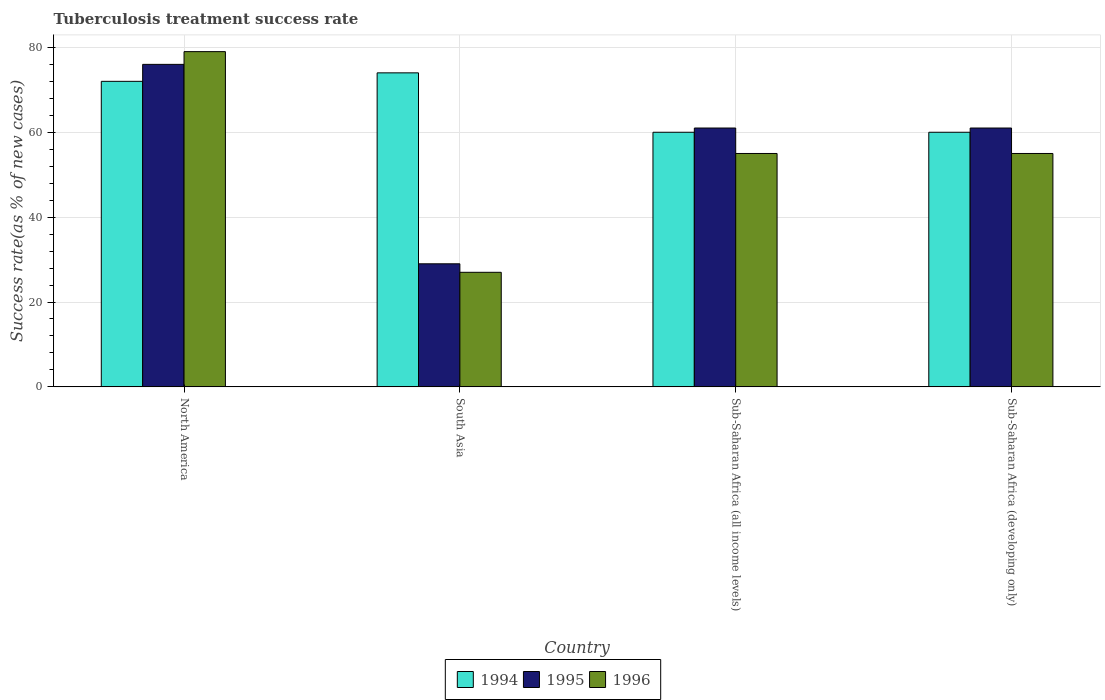How many different coloured bars are there?
Your answer should be very brief. 3. How many groups of bars are there?
Provide a succinct answer. 4. Are the number of bars on each tick of the X-axis equal?
Keep it short and to the point. Yes. How many bars are there on the 1st tick from the right?
Your answer should be very brief. 3. What is the label of the 1st group of bars from the left?
Give a very brief answer. North America. What is the tuberculosis treatment success rate in 1996 in Sub-Saharan Africa (developing only)?
Make the answer very short. 55. What is the total tuberculosis treatment success rate in 1996 in the graph?
Ensure brevity in your answer.  216. What is the difference between the tuberculosis treatment success rate in 1995 in South Asia and that in Sub-Saharan Africa (developing only)?
Offer a terse response. -32. What is the average tuberculosis treatment success rate in 1994 per country?
Your response must be concise. 66.5. In how many countries, is the tuberculosis treatment success rate in 1994 greater than 48 %?
Your answer should be very brief. 4. What is the ratio of the tuberculosis treatment success rate in 1995 in South Asia to that in Sub-Saharan Africa (all income levels)?
Give a very brief answer. 0.48. Is the tuberculosis treatment success rate in 1995 in North America less than that in South Asia?
Offer a very short reply. No. Is the difference between the tuberculosis treatment success rate in 1995 in North America and South Asia greater than the difference between the tuberculosis treatment success rate in 1994 in North America and South Asia?
Your answer should be very brief. Yes. In how many countries, is the tuberculosis treatment success rate in 1996 greater than the average tuberculosis treatment success rate in 1996 taken over all countries?
Keep it short and to the point. 3. Is the sum of the tuberculosis treatment success rate in 1994 in North America and Sub-Saharan Africa (all income levels) greater than the maximum tuberculosis treatment success rate in 1996 across all countries?
Give a very brief answer. Yes. What does the 3rd bar from the left in North America represents?
Offer a very short reply. 1996. How many bars are there?
Offer a very short reply. 12. Are the values on the major ticks of Y-axis written in scientific E-notation?
Your answer should be very brief. No. Does the graph contain any zero values?
Your answer should be very brief. No. Does the graph contain grids?
Provide a succinct answer. Yes. How many legend labels are there?
Provide a short and direct response. 3. What is the title of the graph?
Give a very brief answer. Tuberculosis treatment success rate. Does "1999" appear as one of the legend labels in the graph?
Offer a very short reply. No. What is the label or title of the Y-axis?
Provide a short and direct response. Success rate(as % of new cases). What is the Success rate(as % of new cases) in 1996 in North America?
Keep it short and to the point. 79. What is the Success rate(as % of new cases) in 1996 in Sub-Saharan Africa (all income levels)?
Your answer should be very brief. 55. What is the Success rate(as % of new cases) of 1994 in Sub-Saharan Africa (developing only)?
Ensure brevity in your answer.  60. Across all countries, what is the maximum Success rate(as % of new cases) of 1995?
Provide a succinct answer. 76. Across all countries, what is the maximum Success rate(as % of new cases) of 1996?
Provide a succinct answer. 79. Across all countries, what is the minimum Success rate(as % of new cases) in 1996?
Your answer should be compact. 27. What is the total Success rate(as % of new cases) of 1994 in the graph?
Provide a short and direct response. 266. What is the total Success rate(as % of new cases) in 1995 in the graph?
Your answer should be very brief. 227. What is the total Success rate(as % of new cases) of 1996 in the graph?
Provide a short and direct response. 216. What is the difference between the Success rate(as % of new cases) of 1995 in North America and that in South Asia?
Your answer should be very brief. 47. What is the difference between the Success rate(as % of new cases) of 1996 in North America and that in South Asia?
Provide a succinct answer. 52. What is the difference between the Success rate(as % of new cases) in 1995 in North America and that in Sub-Saharan Africa (all income levels)?
Your response must be concise. 15. What is the difference between the Success rate(as % of new cases) of 1996 in North America and that in Sub-Saharan Africa (all income levels)?
Offer a very short reply. 24. What is the difference between the Success rate(as % of new cases) in 1996 in North America and that in Sub-Saharan Africa (developing only)?
Offer a very short reply. 24. What is the difference between the Success rate(as % of new cases) of 1995 in South Asia and that in Sub-Saharan Africa (all income levels)?
Your response must be concise. -32. What is the difference between the Success rate(as % of new cases) of 1995 in South Asia and that in Sub-Saharan Africa (developing only)?
Make the answer very short. -32. What is the difference between the Success rate(as % of new cases) in 1996 in South Asia and that in Sub-Saharan Africa (developing only)?
Your answer should be compact. -28. What is the difference between the Success rate(as % of new cases) of 1994 in Sub-Saharan Africa (all income levels) and that in Sub-Saharan Africa (developing only)?
Your answer should be compact. 0. What is the difference between the Success rate(as % of new cases) in 1995 in Sub-Saharan Africa (all income levels) and that in Sub-Saharan Africa (developing only)?
Give a very brief answer. 0. What is the difference between the Success rate(as % of new cases) of 1994 in North America and the Success rate(as % of new cases) of 1996 in Sub-Saharan Africa (all income levels)?
Offer a very short reply. 17. What is the difference between the Success rate(as % of new cases) in 1994 in North America and the Success rate(as % of new cases) in 1996 in Sub-Saharan Africa (developing only)?
Make the answer very short. 17. What is the difference between the Success rate(as % of new cases) of 1994 in South Asia and the Success rate(as % of new cases) of 1995 in Sub-Saharan Africa (all income levels)?
Your answer should be compact. 13. What is the difference between the Success rate(as % of new cases) in 1994 in South Asia and the Success rate(as % of new cases) in 1996 in Sub-Saharan Africa (all income levels)?
Provide a short and direct response. 19. What is the difference between the Success rate(as % of new cases) of 1994 in South Asia and the Success rate(as % of new cases) of 1996 in Sub-Saharan Africa (developing only)?
Keep it short and to the point. 19. What is the difference between the Success rate(as % of new cases) in 1994 in Sub-Saharan Africa (all income levels) and the Success rate(as % of new cases) in 1996 in Sub-Saharan Africa (developing only)?
Your answer should be compact. 5. What is the average Success rate(as % of new cases) in 1994 per country?
Keep it short and to the point. 66.5. What is the average Success rate(as % of new cases) in 1995 per country?
Make the answer very short. 56.75. What is the average Success rate(as % of new cases) of 1996 per country?
Ensure brevity in your answer.  54. What is the difference between the Success rate(as % of new cases) of 1994 and Success rate(as % of new cases) of 1995 in North America?
Give a very brief answer. -4. What is the difference between the Success rate(as % of new cases) in 1994 and Success rate(as % of new cases) in 1996 in North America?
Offer a very short reply. -7. What is the difference between the Success rate(as % of new cases) in 1995 and Success rate(as % of new cases) in 1996 in North America?
Ensure brevity in your answer.  -3. What is the difference between the Success rate(as % of new cases) in 1994 and Success rate(as % of new cases) in 1995 in South Asia?
Make the answer very short. 45. What is the difference between the Success rate(as % of new cases) in 1995 and Success rate(as % of new cases) in 1996 in South Asia?
Your answer should be very brief. 2. What is the difference between the Success rate(as % of new cases) of 1994 and Success rate(as % of new cases) of 1995 in Sub-Saharan Africa (all income levels)?
Keep it short and to the point. -1. What is the difference between the Success rate(as % of new cases) in 1994 and Success rate(as % of new cases) in 1996 in Sub-Saharan Africa (all income levels)?
Provide a succinct answer. 5. What is the ratio of the Success rate(as % of new cases) of 1995 in North America to that in South Asia?
Keep it short and to the point. 2.62. What is the ratio of the Success rate(as % of new cases) of 1996 in North America to that in South Asia?
Keep it short and to the point. 2.93. What is the ratio of the Success rate(as % of new cases) in 1994 in North America to that in Sub-Saharan Africa (all income levels)?
Your response must be concise. 1.2. What is the ratio of the Success rate(as % of new cases) in 1995 in North America to that in Sub-Saharan Africa (all income levels)?
Make the answer very short. 1.25. What is the ratio of the Success rate(as % of new cases) of 1996 in North America to that in Sub-Saharan Africa (all income levels)?
Keep it short and to the point. 1.44. What is the ratio of the Success rate(as % of new cases) of 1995 in North America to that in Sub-Saharan Africa (developing only)?
Your answer should be very brief. 1.25. What is the ratio of the Success rate(as % of new cases) in 1996 in North America to that in Sub-Saharan Africa (developing only)?
Your answer should be compact. 1.44. What is the ratio of the Success rate(as % of new cases) in 1994 in South Asia to that in Sub-Saharan Africa (all income levels)?
Provide a succinct answer. 1.23. What is the ratio of the Success rate(as % of new cases) in 1995 in South Asia to that in Sub-Saharan Africa (all income levels)?
Offer a terse response. 0.48. What is the ratio of the Success rate(as % of new cases) of 1996 in South Asia to that in Sub-Saharan Africa (all income levels)?
Keep it short and to the point. 0.49. What is the ratio of the Success rate(as % of new cases) of 1994 in South Asia to that in Sub-Saharan Africa (developing only)?
Give a very brief answer. 1.23. What is the ratio of the Success rate(as % of new cases) of 1995 in South Asia to that in Sub-Saharan Africa (developing only)?
Give a very brief answer. 0.48. What is the ratio of the Success rate(as % of new cases) of 1996 in South Asia to that in Sub-Saharan Africa (developing only)?
Keep it short and to the point. 0.49. What is the ratio of the Success rate(as % of new cases) in 1994 in Sub-Saharan Africa (all income levels) to that in Sub-Saharan Africa (developing only)?
Make the answer very short. 1. What is the ratio of the Success rate(as % of new cases) of 1995 in Sub-Saharan Africa (all income levels) to that in Sub-Saharan Africa (developing only)?
Your answer should be very brief. 1. What is the difference between the highest and the lowest Success rate(as % of new cases) of 1994?
Offer a terse response. 14. What is the difference between the highest and the lowest Success rate(as % of new cases) in 1995?
Your answer should be very brief. 47. What is the difference between the highest and the lowest Success rate(as % of new cases) of 1996?
Your answer should be very brief. 52. 